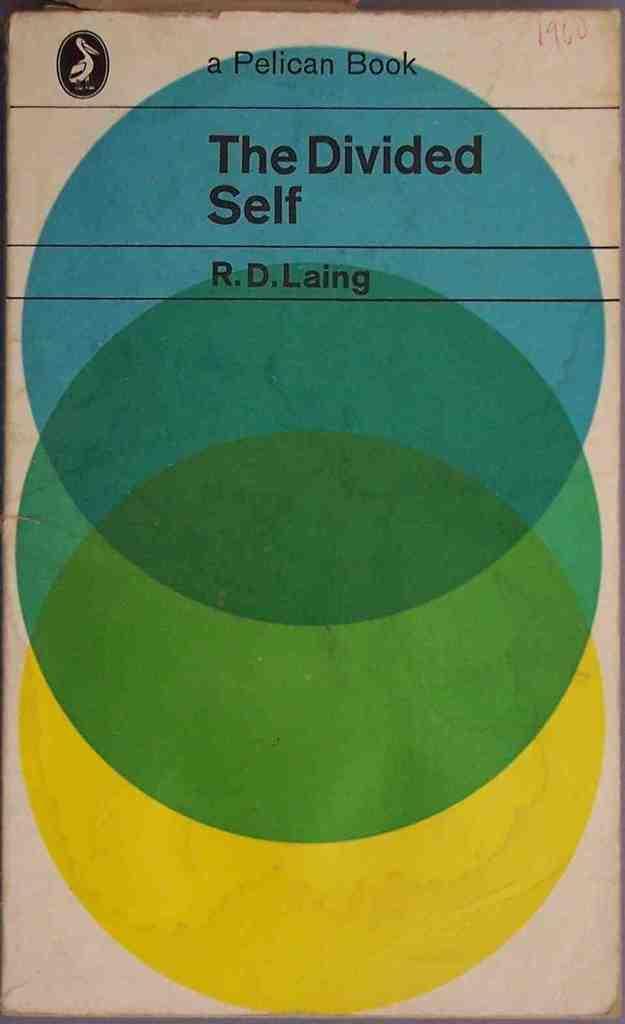Please provide a concise description of this image. In this image there is a book, on that there is some text and color circles. 